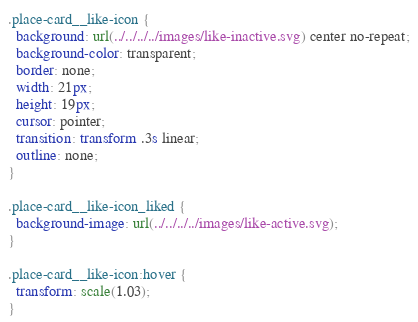<code> <loc_0><loc_0><loc_500><loc_500><_CSS_>.place-card__like-icon {
  background: url(../../../../images/like-inactive.svg) center no-repeat;
  background-color: transparent;
  border: none;
  width: 21px;
  height: 19px;
  cursor: pointer;
  transition: transform .3s linear;
  outline: none;
}

.place-card__like-icon_liked {
  background-image: url(../../../../images/like-active.svg);
}

.place-card__like-icon:hover {
  transform: scale(1.03);
}
</code> 